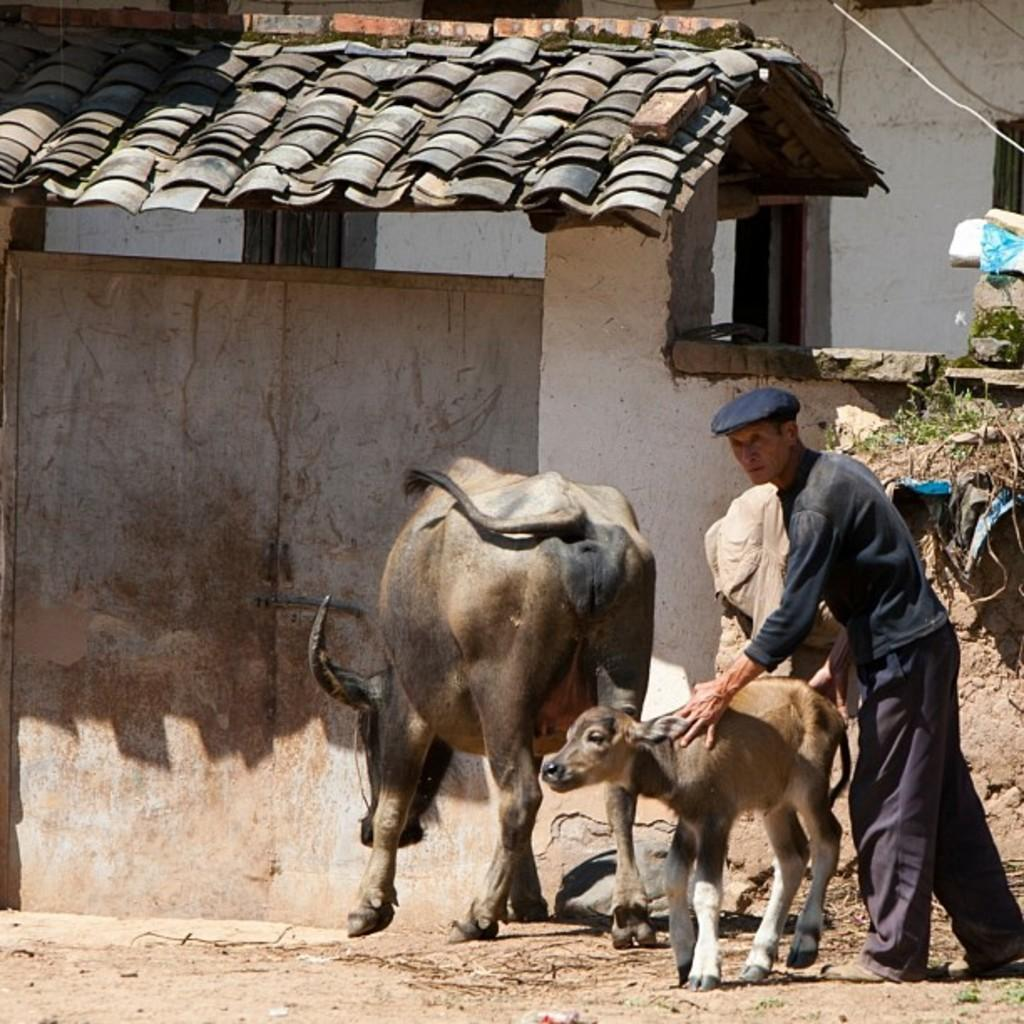What type of animal is the main subject of the image? There is a buffalo in the image. Is there a baby animal present in the image? Yes, there is a calf in the image. Where are the buffalo and calf located in relation to the home? The buffalo and calf are standing in front of a home. Who else is present in the image? There is a man in the image. What is the man doing in the image? The man is standing with the buffalo and calf. Can you describe the man's attire in the image? The man is wearing a black cap on his head. How many snakes are slithering around the buffalo and calf in the image? There are no snakes present in the image; it features a buffalo, a calf, and a man. What type of scene is depicted in the image? The image depicts a scene of a man standing with a buffalo and calf in front of a home. 